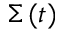Convert formula to latex. <formula><loc_0><loc_0><loc_500><loc_500>\Sigma \, ( t )</formula> 